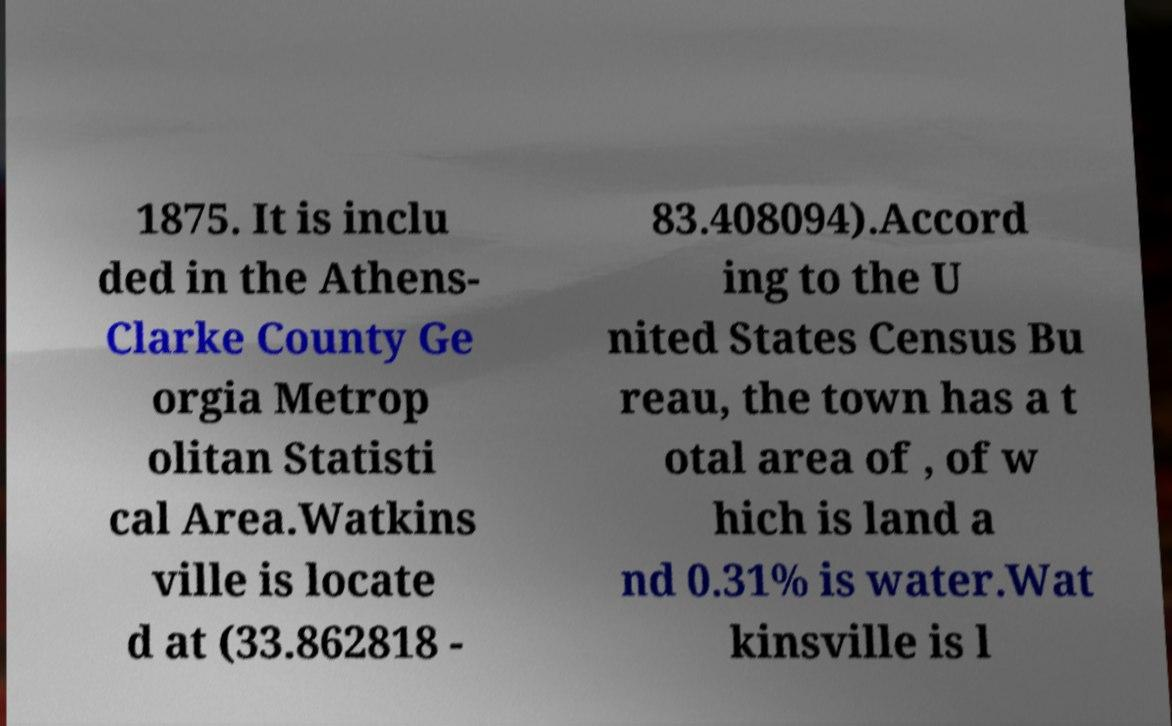I need the written content from this picture converted into text. Can you do that? 1875. It is inclu ded in the Athens- Clarke County Ge orgia Metrop olitan Statisti cal Area.Watkins ville is locate d at (33.862818 - 83.408094).Accord ing to the U nited States Census Bu reau, the town has a t otal area of , of w hich is land a nd 0.31% is water.Wat kinsville is l 